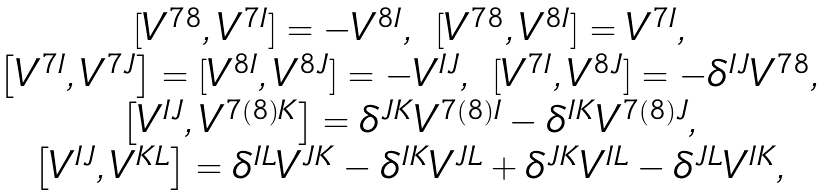Convert formula to latex. <formula><loc_0><loc_0><loc_500><loc_500>\begin{array} { c } [ V ^ { 7 8 } , V ^ { 7 I } ] = - V ^ { 8 I } , \ [ V ^ { 7 8 } , V ^ { 8 I } ] = V ^ { 7 I } , \\ \left [ V ^ { 7 I } , V ^ { 7 J } \right ] = [ V ^ { 8 I } , V ^ { 8 J } ] = - V ^ { I J } , \ [ V ^ { 7 I } , V ^ { 8 J } ] = - \delta ^ { I J } V ^ { 7 8 } , \\ \left [ V ^ { I J } , V ^ { 7 ( 8 ) K } \right ] = \delta ^ { J K } V ^ { 7 ( 8 ) I } - \delta ^ { I K } V ^ { 7 ( 8 ) J } , \\ \left [ V ^ { I J } , V ^ { K L } \right ] = \delta ^ { I L } V ^ { J K } - \delta ^ { I K } V ^ { J L } + \delta ^ { J K } V ^ { I L } - \delta ^ { J L } V ^ { I K } , \end{array}</formula> 